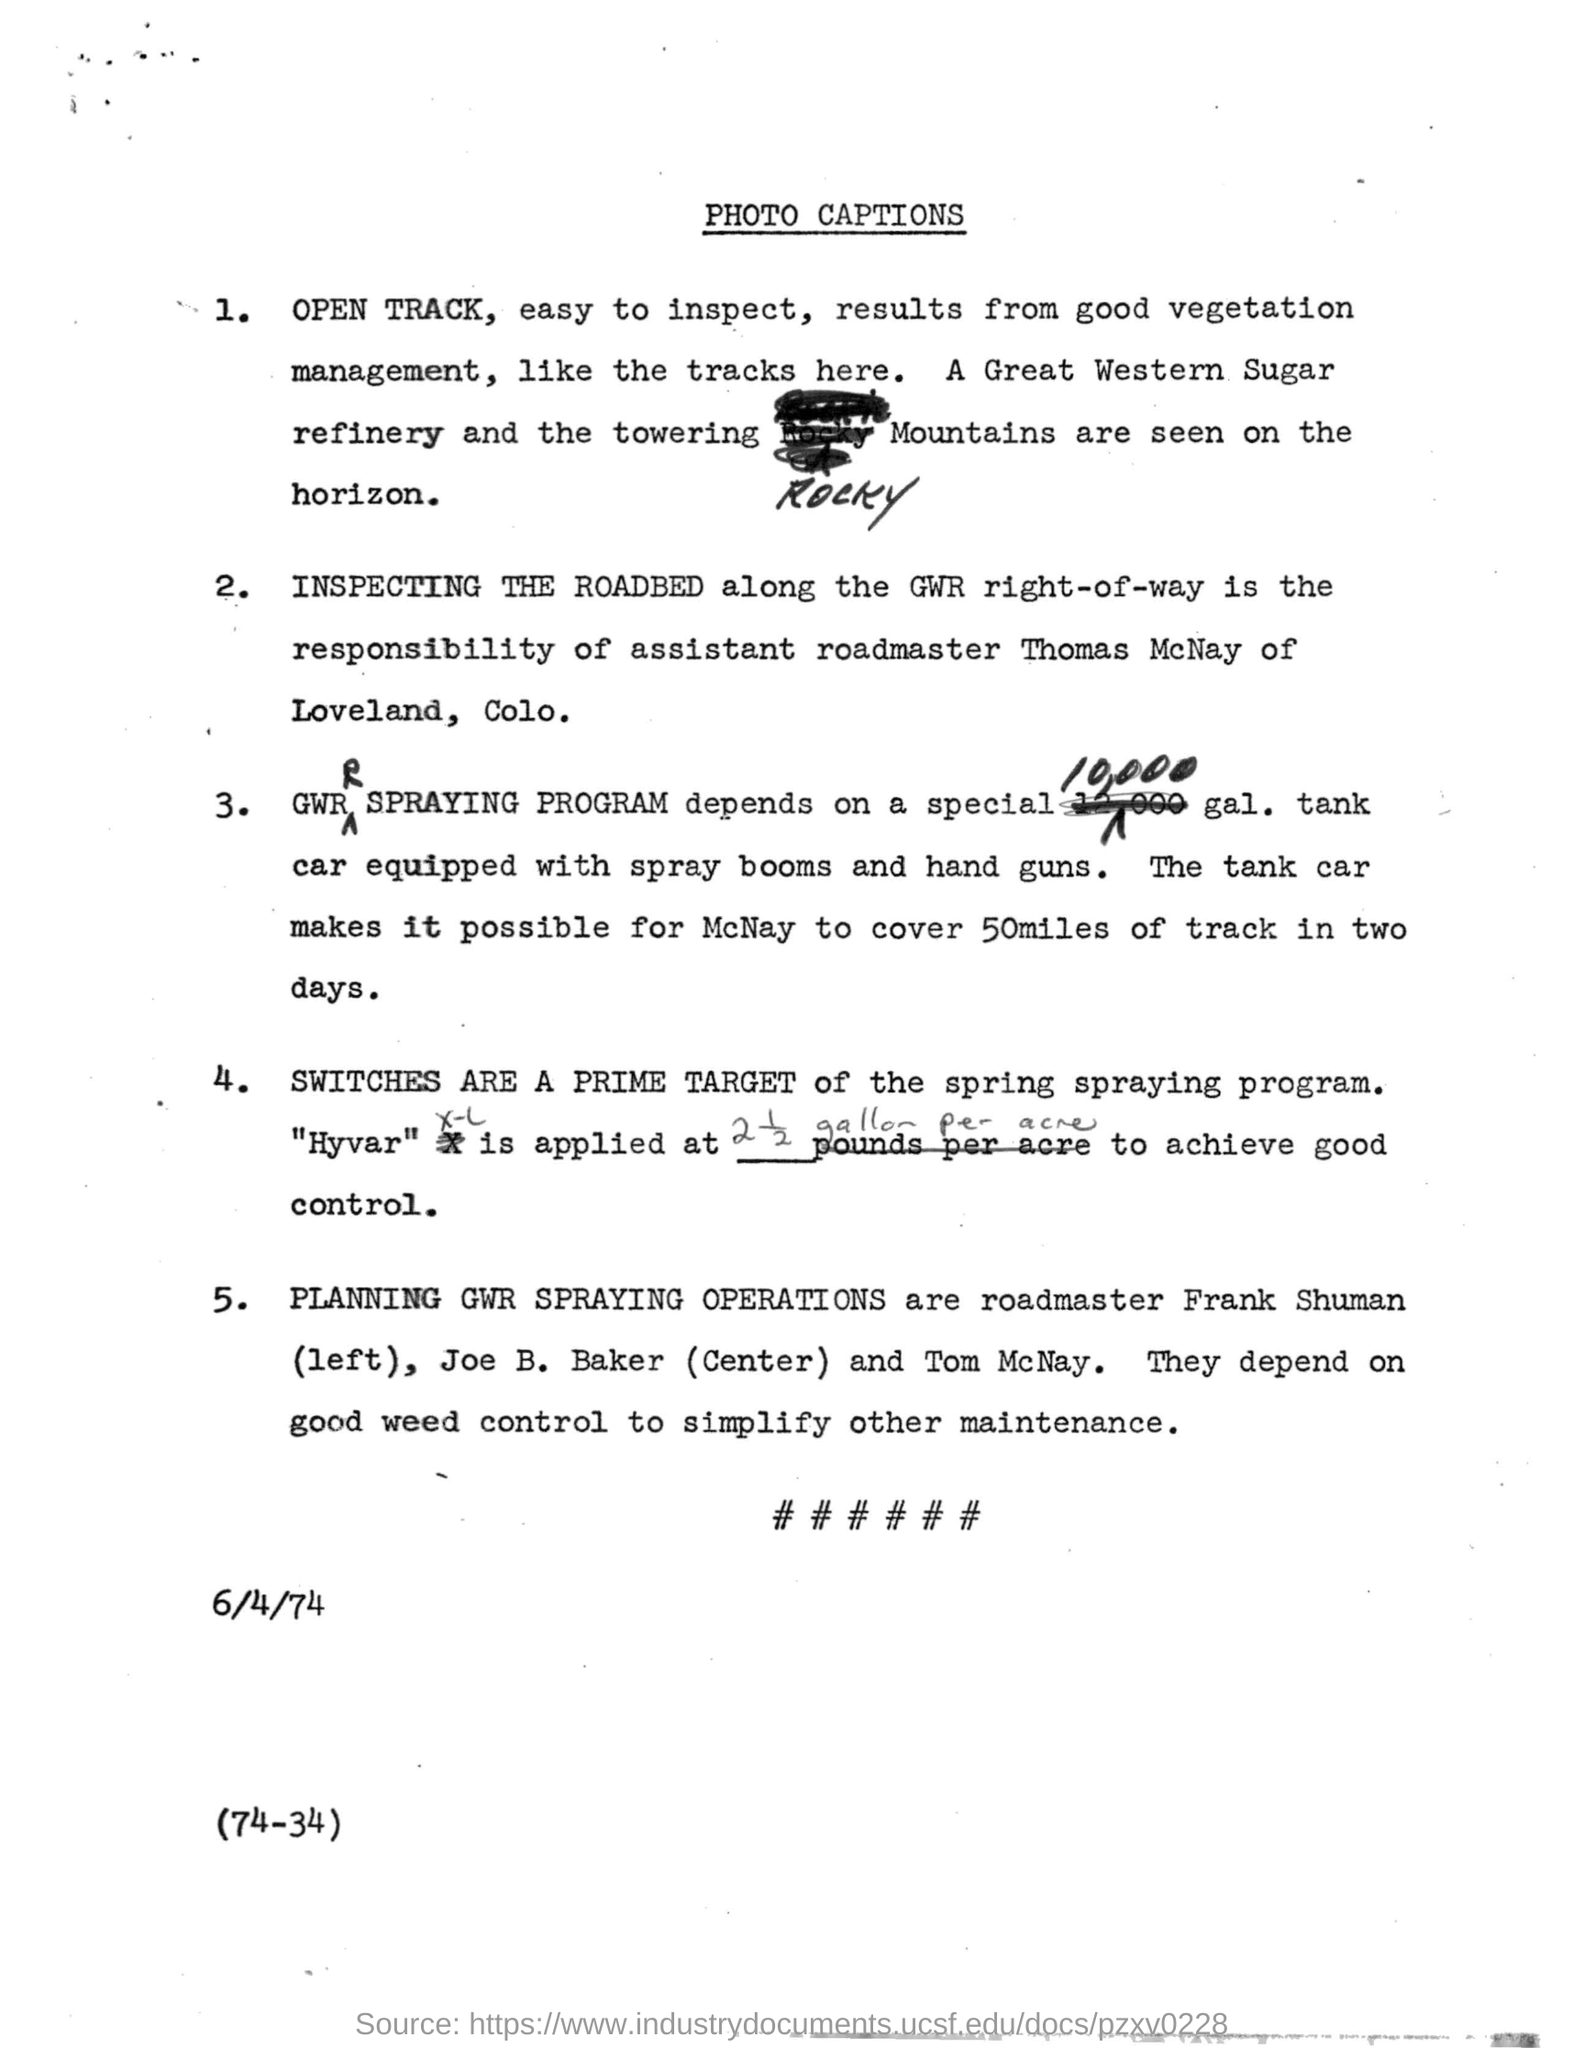Who is the assistant roadmaster of Loveland?
Offer a terse response. Thomas McNay. How many miles McNay can cover in two days?
Provide a short and direct response. 50 miles. What is the prime target of the spring spraying program?
Give a very brief answer. SWITCHES. What is the date mentioned in the document?
Ensure brevity in your answer.  6/4/74. What is the name of the document?
Offer a terse response. Photo Captions. What is the date given in the document?
Offer a very short reply. 6/4/74. 